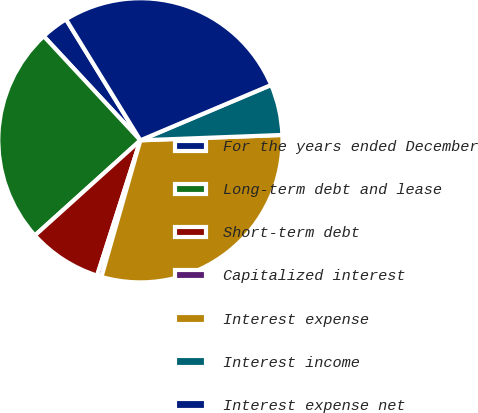Convert chart. <chart><loc_0><loc_0><loc_500><loc_500><pie_chart><fcel>For the years ended December<fcel>Long-term debt and lease<fcel>Short-term debt<fcel>Capitalized interest<fcel>Interest expense<fcel>Interest income<fcel>Interest expense net<nl><fcel>3.14%<fcel>24.77%<fcel>8.39%<fcel>0.51%<fcel>30.02%<fcel>5.77%<fcel>27.4%<nl></chart> 